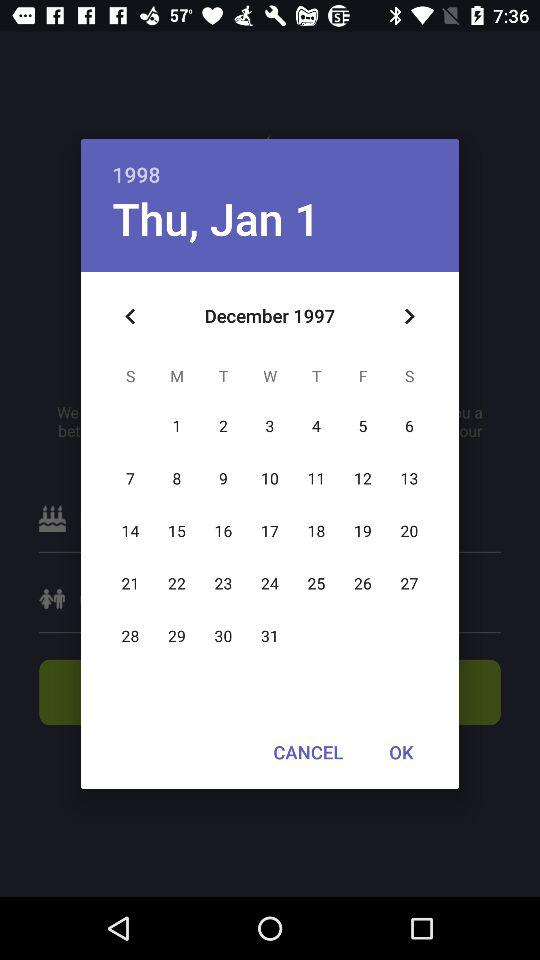What was the day on the 01st of January 1998? The day was Thursday on the 01st of January 1998. 